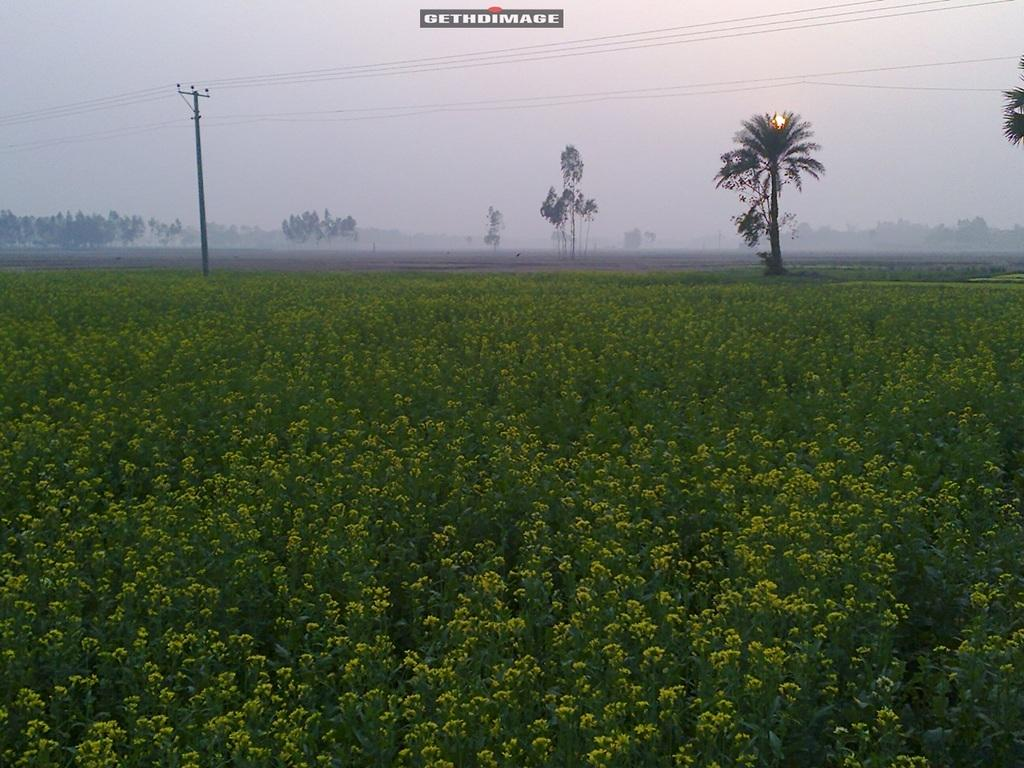What type of living organisms can be seen in the image? Plants can be seen in the image. What man-made structure is present in the image? There is an electric pole with cables in the image. What can be seen in the background of the image? Trees and the sky are visible in the background of the image. What type of powder is being used to enhance the experience of the low-hanging branches in the image? There is no powder or low-hanging branches present in the image. 